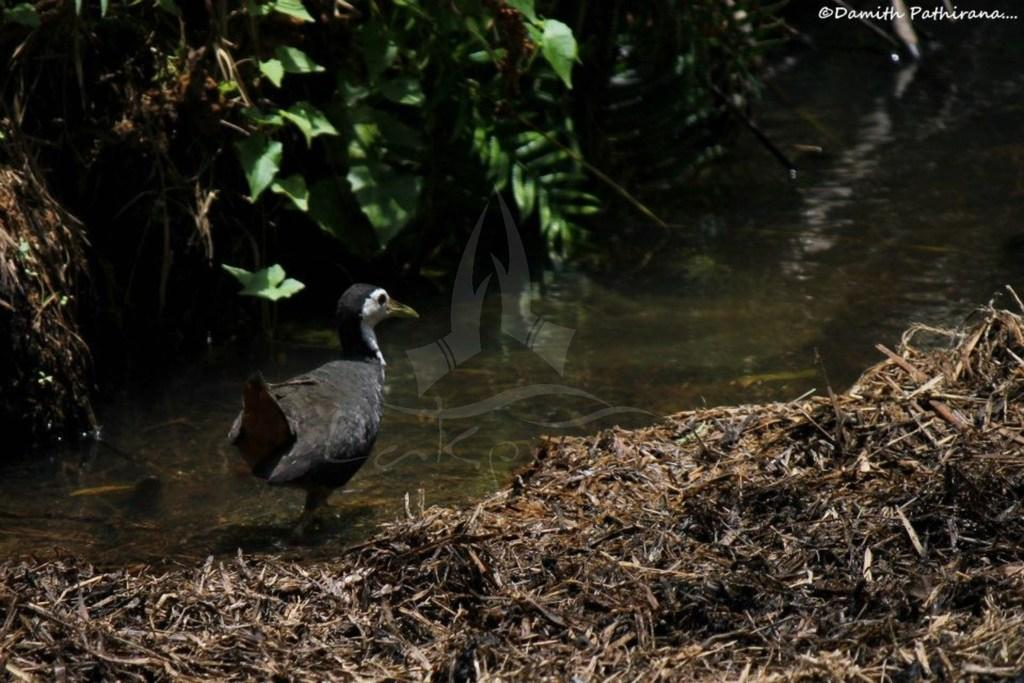What is the main subject of the image? The main subject of the image is a bird on the surface of the water. What type of vegetation is present at the right bottom of the image? Dry grass is present at the right bottom of the image. What can be seen at the top of the image? Leaves are visible at the top of the image. What type of behavior is the bird exhibiting in the image? The image does not provide information about the bird's behavior, only its location on the water. What is the caption for the image? The image does not have a caption; we are only describing the contents of the image based on the provided facts. 